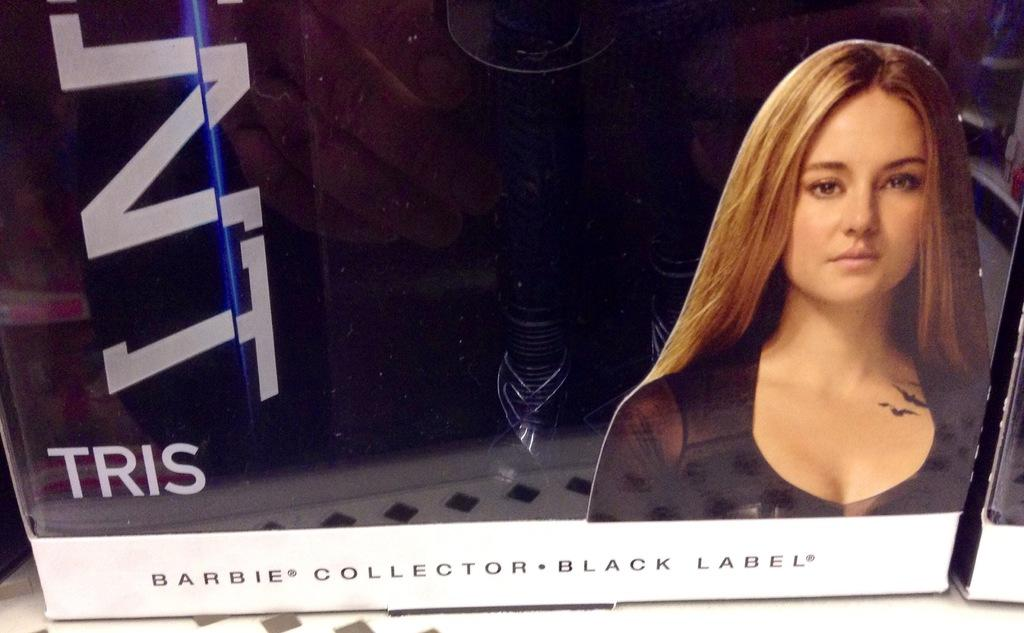What is the main object in the image? There is a card box in the image. What can be found on the card box? The card box has text on it and an image of a woman. What is the card box placed on? The card box is placed on a white surface. What else can be seen in the image? There is an object on the right side of the image. What type of quiver is visible in the image? There is no quiver present in the image. What color are the trousers worn by the woman on the card box? The image on the card box shows a woman, but it does not provide enough detail to determine the color of her trousers. 